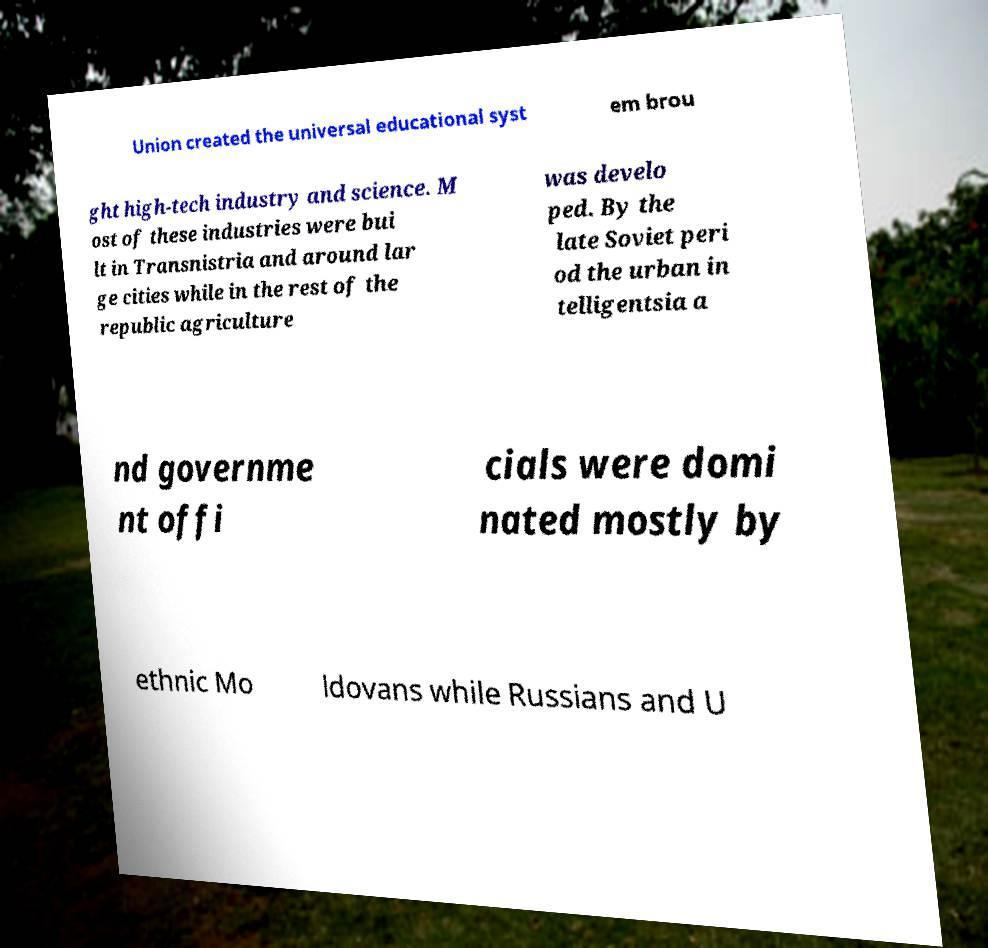Could you extract and type out the text from this image? Union created the universal educational syst em brou ght high-tech industry and science. M ost of these industries were bui lt in Transnistria and around lar ge cities while in the rest of the republic agriculture was develo ped. By the late Soviet peri od the urban in telligentsia a nd governme nt offi cials were domi nated mostly by ethnic Mo ldovans while Russians and U 